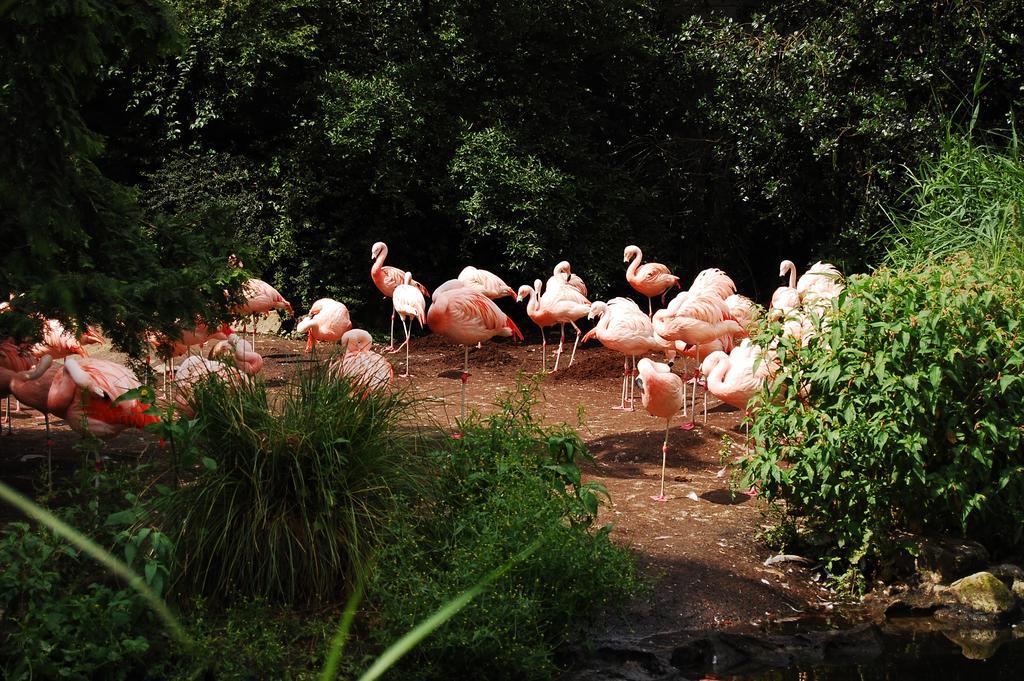How would you summarize this image in a sentence or two? This picture contains many swans. There are trees in the background. At the bottom of the picture, we see pants and in the right bottom, we see water. 